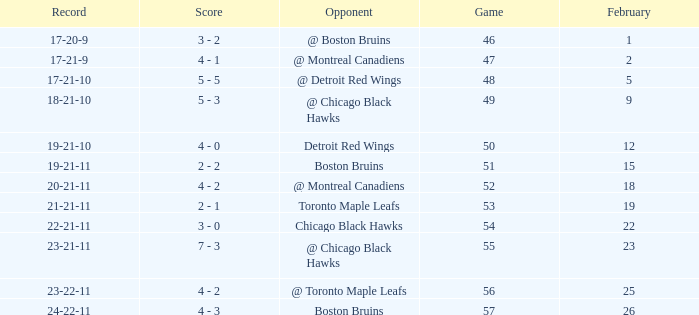What was the score of the game 57 after February 23? 4 - 3. 